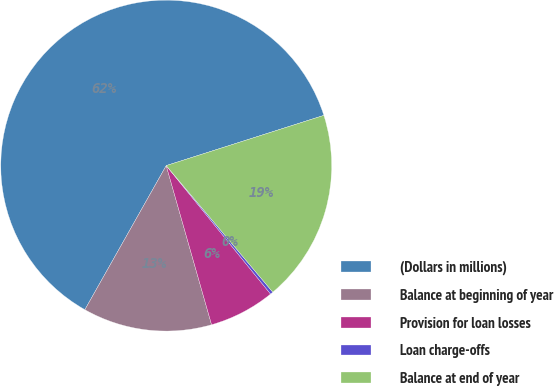<chart> <loc_0><loc_0><loc_500><loc_500><pie_chart><fcel>(Dollars in millions)<fcel>Balance at beginning of year<fcel>Provision for loan losses<fcel>Loan charge-offs<fcel>Balance at end of year<nl><fcel>61.91%<fcel>12.6%<fcel>6.44%<fcel>0.28%<fcel>18.77%<nl></chart> 